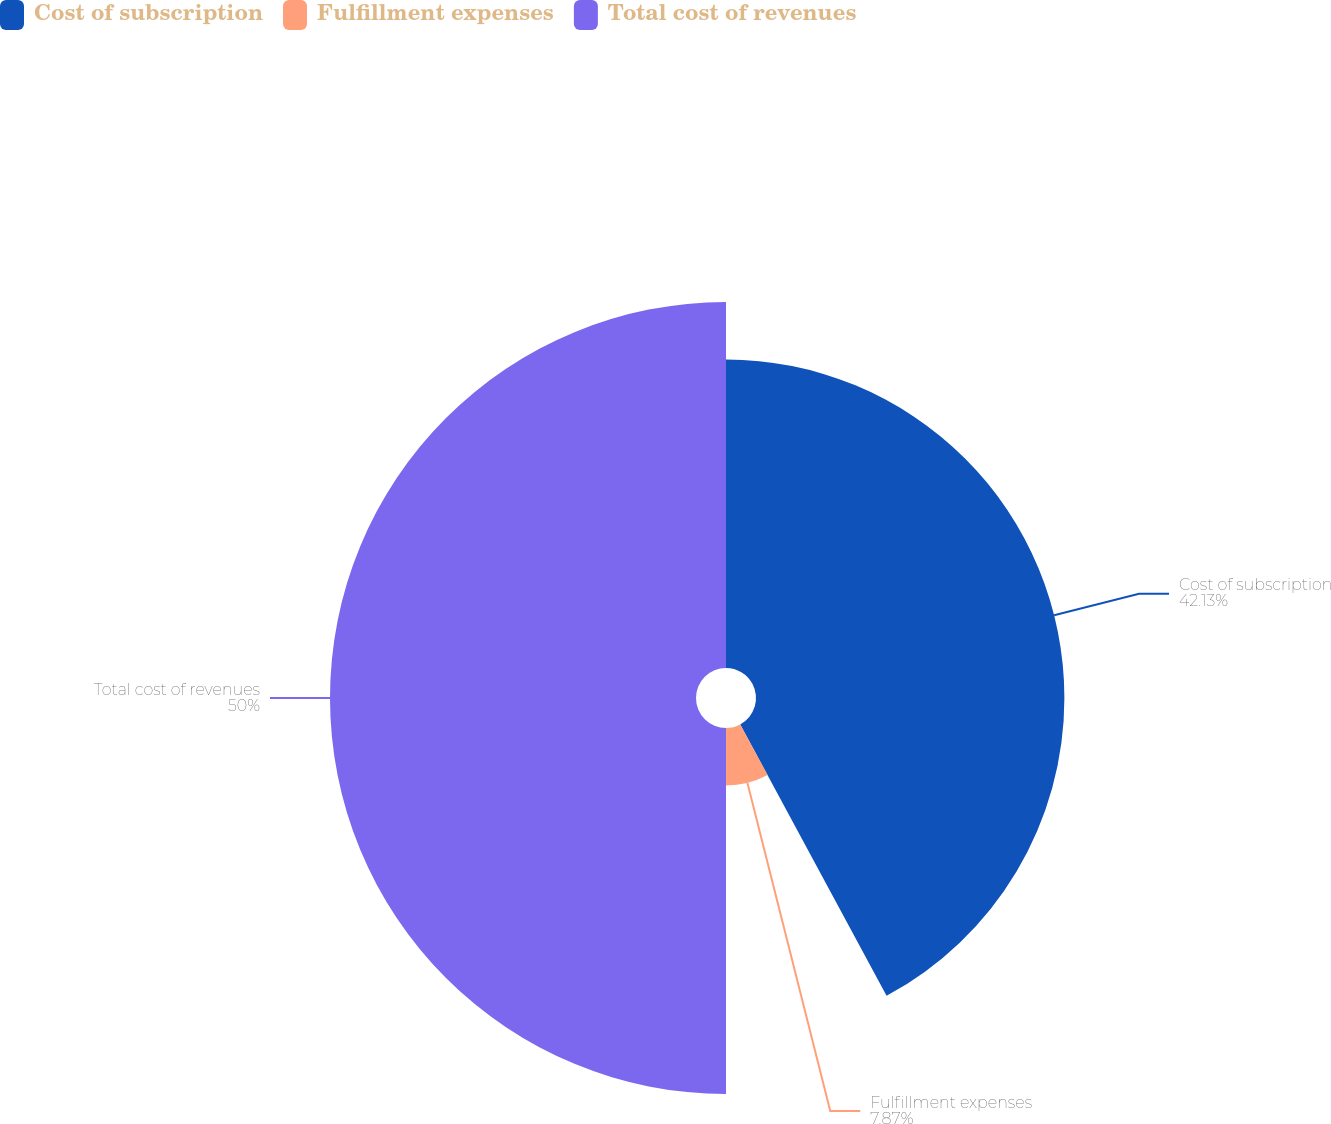Convert chart to OTSL. <chart><loc_0><loc_0><loc_500><loc_500><pie_chart><fcel>Cost of subscription<fcel>Fulfillment expenses<fcel>Total cost of revenues<nl><fcel>42.13%<fcel>7.87%<fcel>50.0%<nl></chart> 